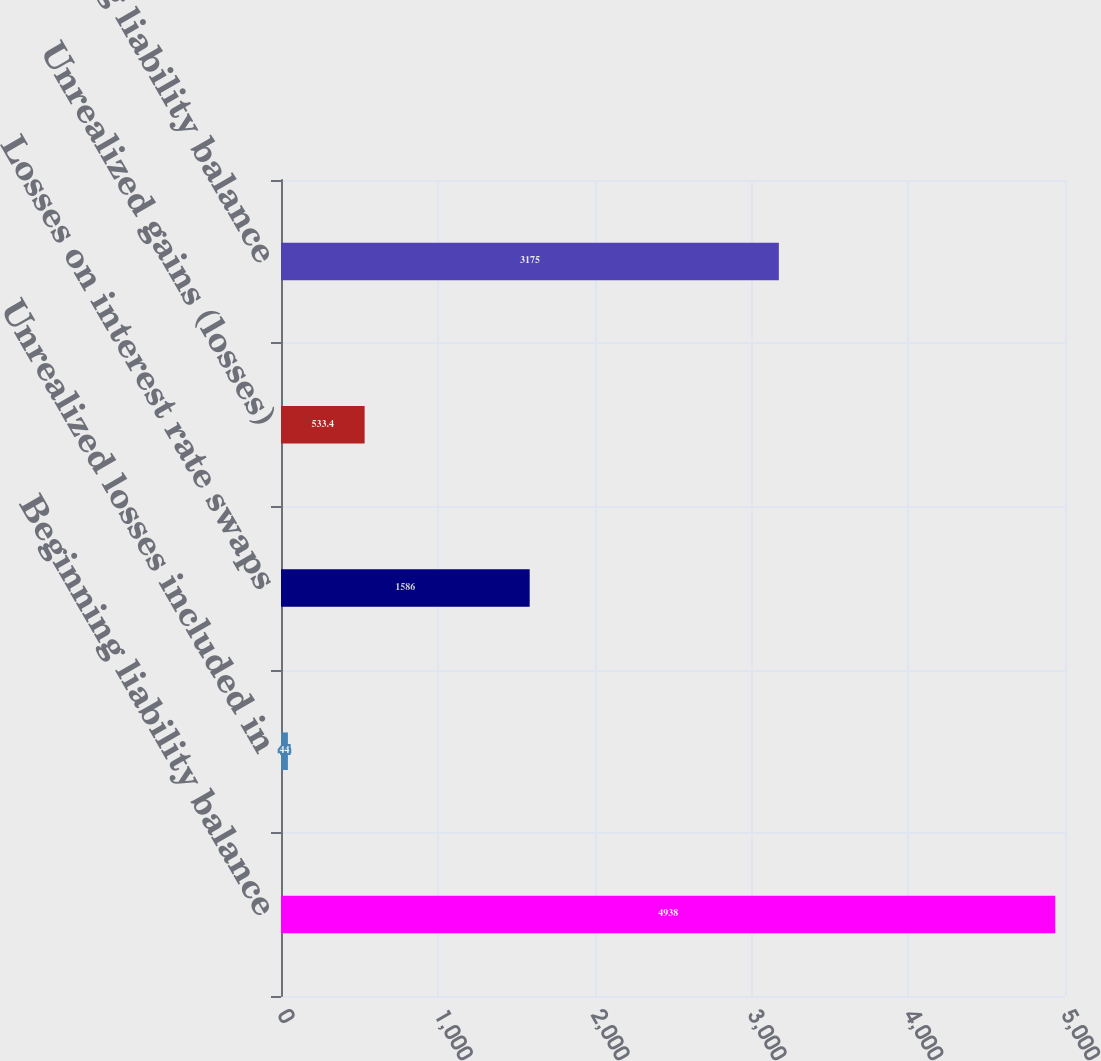Convert chart. <chart><loc_0><loc_0><loc_500><loc_500><bar_chart><fcel>Beginning liability balance<fcel>Unrealized losses included in<fcel>Losses on interest rate swaps<fcel>Unrealized gains (losses)<fcel>Ending liability balance<nl><fcel>4938<fcel>44<fcel>1586<fcel>533.4<fcel>3175<nl></chart> 